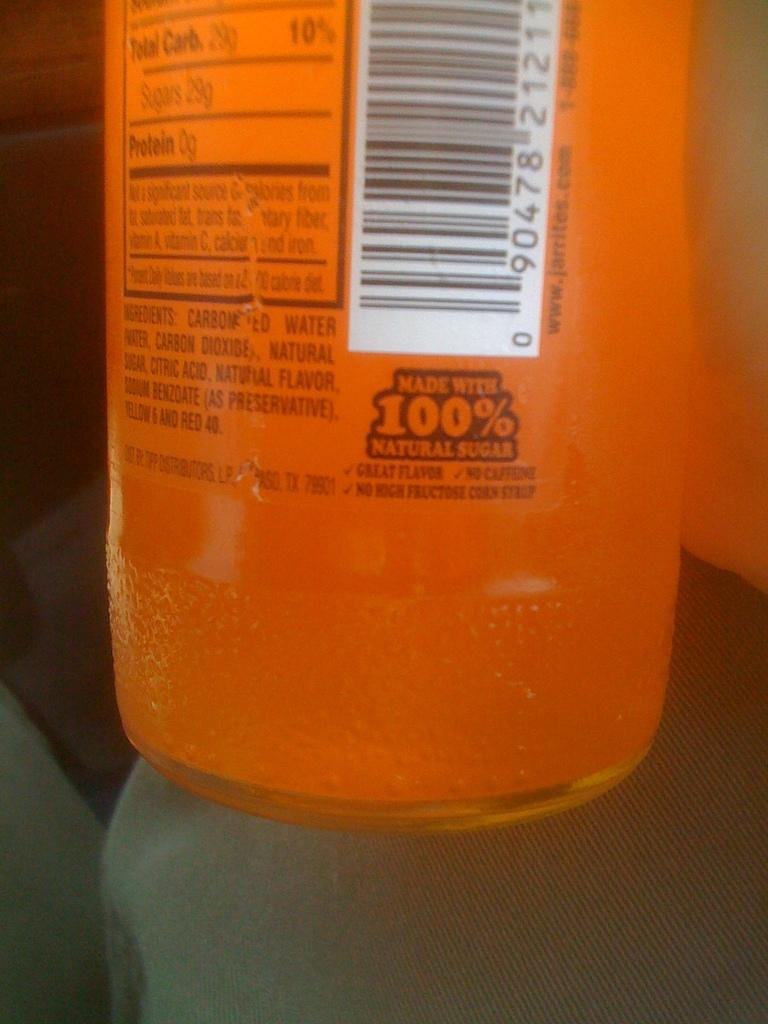<image>
Write a terse but informative summary of the picture. An orange bottle with the ingredients listed on the back 